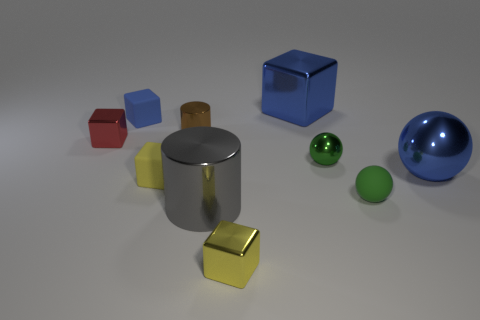Is the tiny cylinder made of the same material as the blue cube to the left of the yellow matte cube?
Give a very brief answer. No. What shape is the blue object that is on the right side of the tiny yellow rubber object and behind the blue shiny ball?
Ensure brevity in your answer.  Cube. How many other objects are the same color as the small metallic sphere?
Provide a succinct answer. 1. What is the shape of the tiny yellow matte object?
Offer a terse response. Cube. What is the color of the cylinder that is behind the tiny yellow rubber thing in front of the big shiny sphere?
Give a very brief answer. Brown. There is a large metallic sphere; is its color the same as the tiny matte sphere right of the brown cylinder?
Keep it short and to the point. No. What material is the tiny block that is both on the right side of the small blue rubber cube and behind the gray cylinder?
Your response must be concise. Rubber. Are there any cylinders of the same size as the gray shiny thing?
Your answer should be compact. No. What is the material of the red block that is the same size as the brown cylinder?
Make the answer very short. Metal. How many small matte blocks are on the left side of the red cube?
Offer a terse response. 0. 